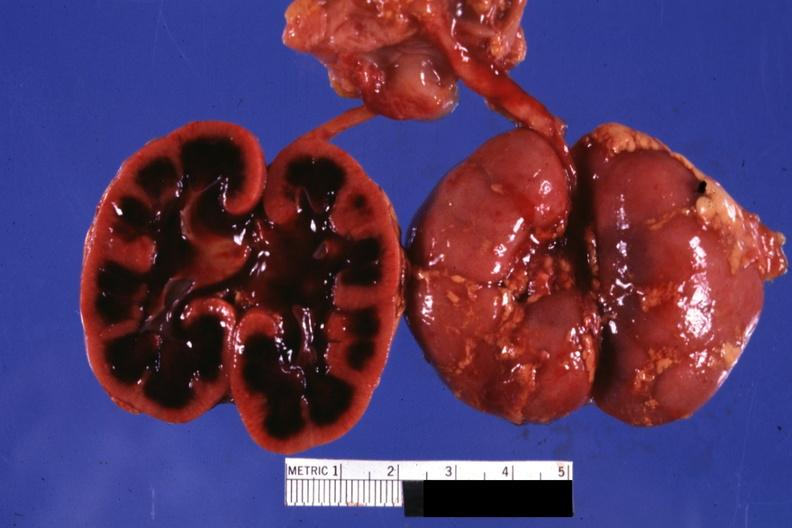s horseshoe kidney present?
Answer the question using a single word or phrase. No 